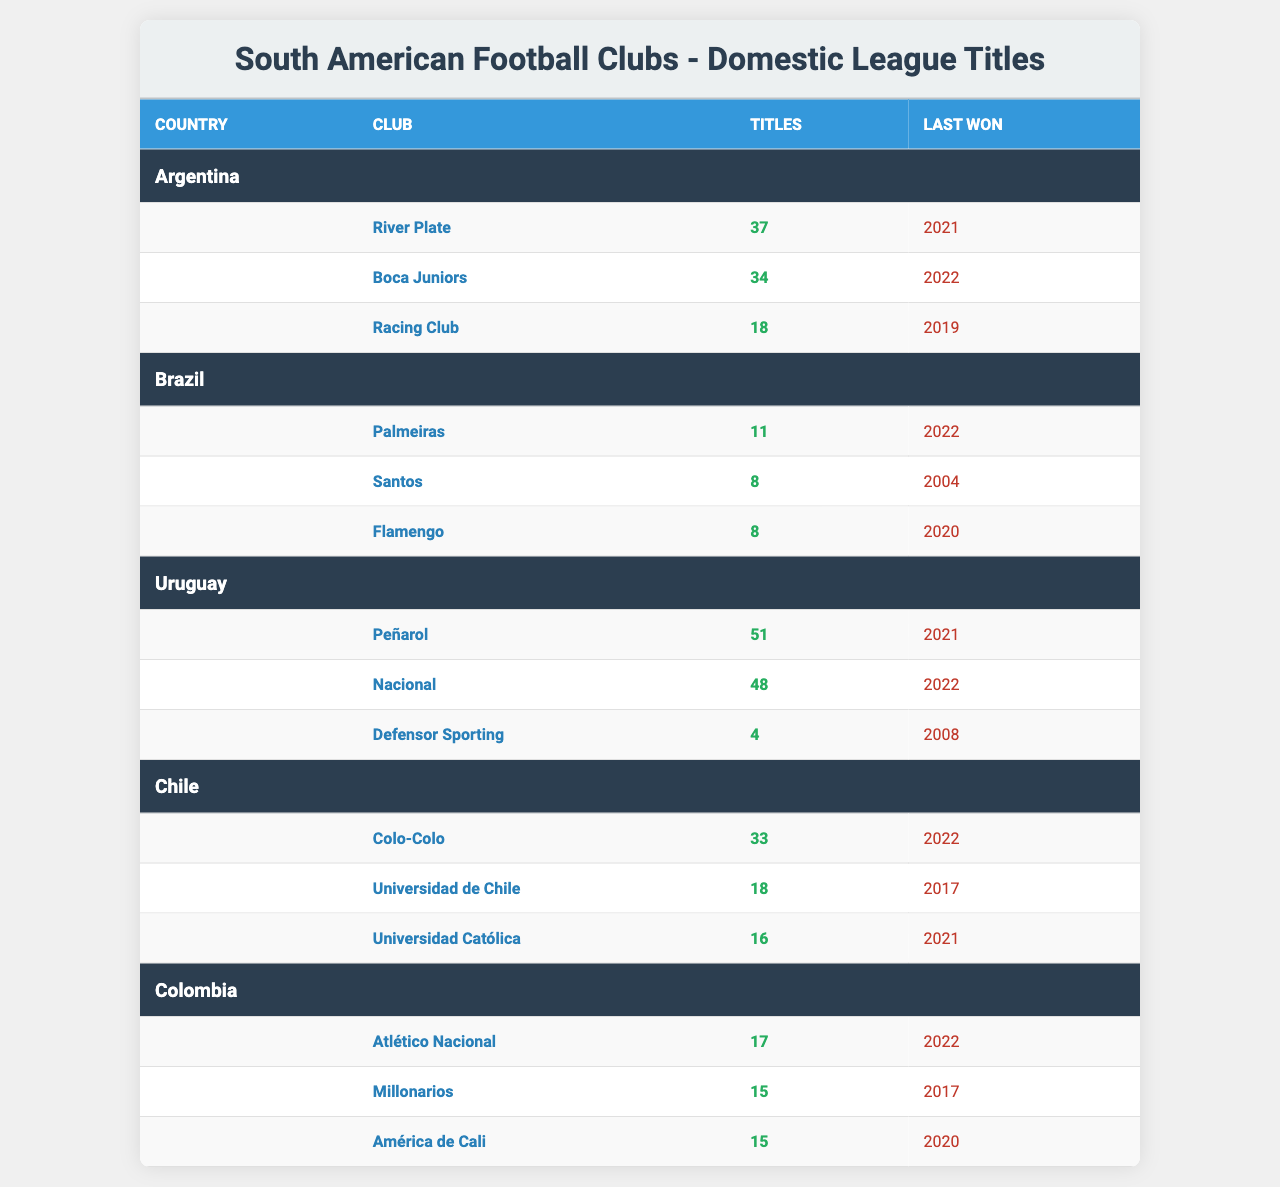What is the club with the most domestic league titles in Argentina? Looking at the Argentina section of the table, River Plate has the highest number of titles at 37.
Answer: River Plate Which Uruguayan club has won the most league titles? The table for Uruguay shows Peñarol with 51 titles, which is more than Nacional, who has 48.
Answer: Peñarol How many titles has Atlético Nacional won? Referring to the Colombia section, Atlético Nacional is listed with a total of 17 titles.
Answer: 17 What is the total number of domestic league titles won by clubs in Chile? Summing up the titles from the Chile section: 33 (Colo-Colo) + 18 (Universidad de Chile) + 16 (Universidad Católica) = 67 total titles.
Answer: 67 Has Nacional won more league titles than Boca Juniors? Nacional has 48 titles while Boca Juniors has 34. Since 48 is greater than 34, the statement is true.
Answer: Yes Which Brazilian club last won the league title most recently? The table indicates Palmeiras last won in 2022, while Santos and Flamengo last won in 2004 and 2020 respectively. Hence, Palmeiras is the most recent title holder.
Answer: Palmeiras What is the average number of titles for clubs in Brazil? To find the average, sum the titles: 11 (Palmeiras) + 8 (Santos) + 8 (Flamengo) = 27. There are 3 clubs, so the average is 27/3 = 9.
Answer: 9 What is the difference in title count between Peñarol and River Plate? Peñarol has 51 titles and River Plate has 37. The difference is 51 - 37 = 14 titles.
Answer: 14 Which two clubs have the same number of domestic league titles in Colombia? The table shows Millonarios and América de Cali both have 15 titles, indicating they are equal in count.
Answer: Millonarios and América de Cali Which club has won the league title most recently among all clubs? The last won columns show Boca Juniors won in 2022, while there are others from the same year but with titles lower than Boca Juniors. Therefore, Boca Juniors is the most recent.
Answer: Boca Juniors 